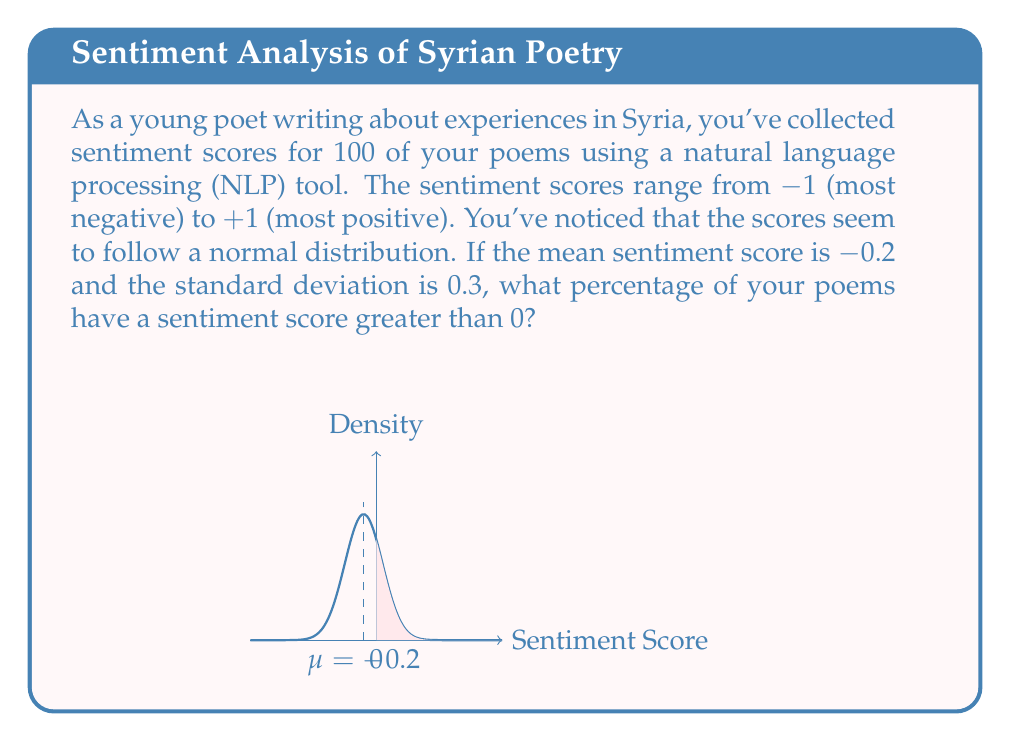Provide a solution to this math problem. To solve this problem, we need to use the properties of the normal distribution and the concept of z-scores. Let's break it down step-by-step:

1) We're given:
   - Mean (μ) = -0.2
   - Standard deviation (σ) = 0.3
   - We want to find the percentage of poems with a score > 0

2) To find the percentage above 0, we need to calculate the z-score for 0:

   $$z = \frac{x - \mu}{\sigma} = \frac{0 - (-0.2)}{0.3} = \frac{0.2}{0.3} \approx 0.667$$

3) This z-score represents the number of standard deviations that 0 is above the mean.

4) Now, we need to find the area to the right of this z-score in the standard normal distribution. This represents the proportion of poems with a score greater than 0.

5) We can use a standard normal table or a statistical calculator for this. The area to the right of z = 0.667 is approximately 0.2524.

6) To convert this to a percentage, we multiply by 100:

   0.2524 * 100 ≈ 25.24%

Therefore, approximately 25.24% of the poems have a sentiment score greater than 0.
Answer: 25.24% 